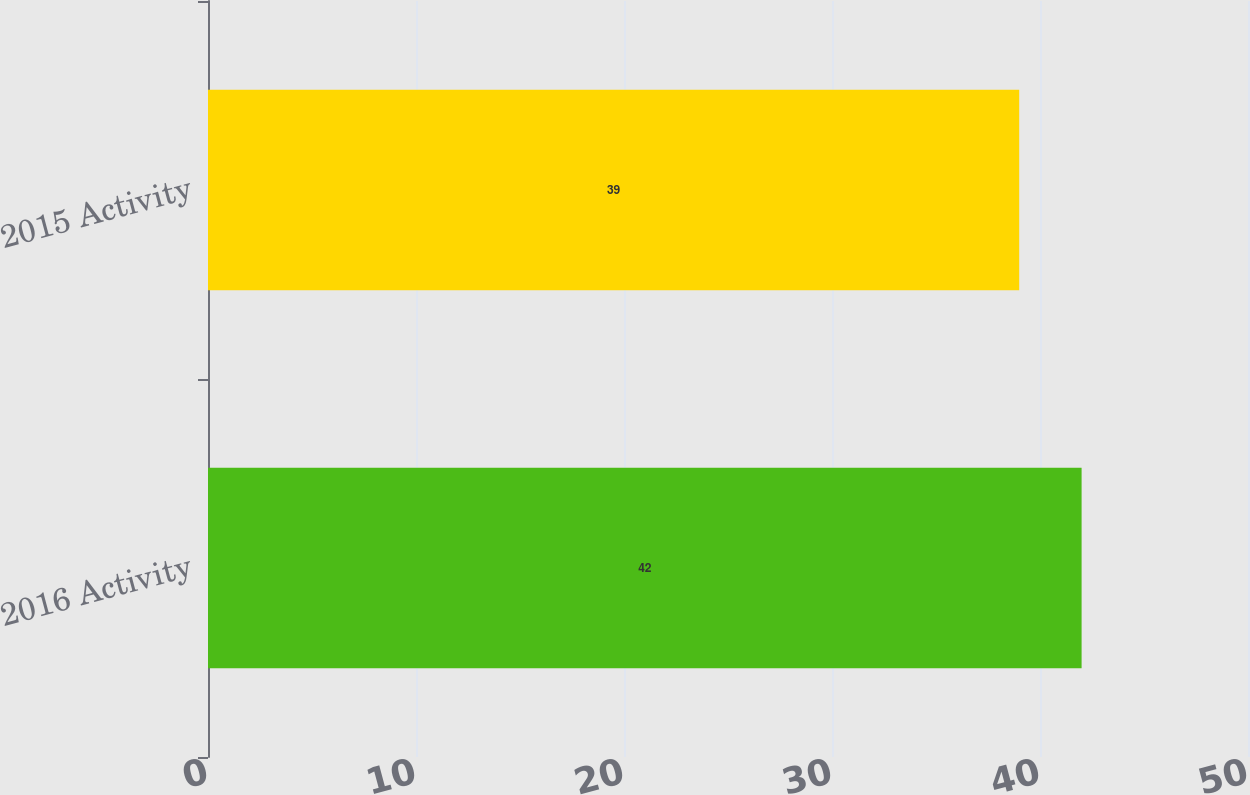Convert chart. <chart><loc_0><loc_0><loc_500><loc_500><bar_chart><fcel>2016 Activity<fcel>2015 Activity<nl><fcel>42<fcel>39<nl></chart> 